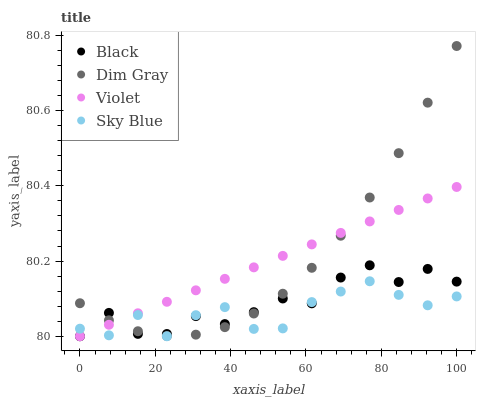Does Sky Blue have the minimum area under the curve?
Answer yes or no. Yes. Does Dim Gray have the maximum area under the curve?
Answer yes or no. Yes. Does Black have the minimum area under the curve?
Answer yes or no. No. Does Black have the maximum area under the curve?
Answer yes or no. No. Is Violet the smoothest?
Answer yes or no. Yes. Is Black the roughest?
Answer yes or no. Yes. Is Dim Gray the smoothest?
Answer yes or no. No. Is Dim Gray the roughest?
Answer yes or no. No. Does Sky Blue have the lowest value?
Answer yes or no. Yes. Does Dim Gray have the lowest value?
Answer yes or no. No. Does Dim Gray have the highest value?
Answer yes or no. Yes. Does Black have the highest value?
Answer yes or no. No. Does Dim Gray intersect Sky Blue?
Answer yes or no. Yes. Is Dim Gray less than Sky Blue?
Answer yes or no. No. Is Dim Gray greater than Sky Blue?
Answer yes or no. No. 